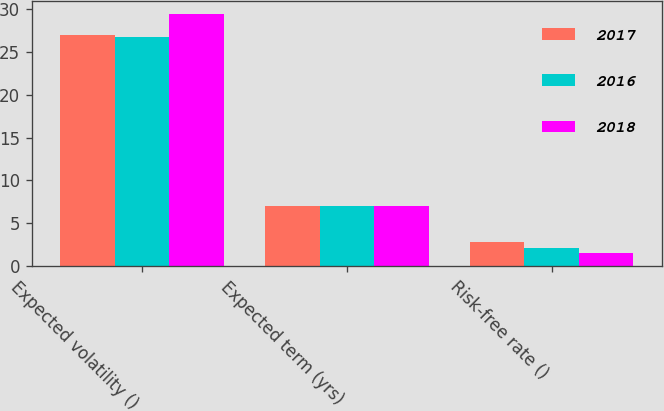Convert chart to OTSL. <chart><loc_0><loc_0><loc_500><loc_500><stacked_bar_chart><ecel><fcel>Expected volatility ()<fcel>Expected term (yrs)<fcel>Risk-free rate ()<nl><fcel>2017<fcel>27<fcel>7<fcel>2.8<nl><fcel>2016<fcel>26.7<fcel>7<fcel>2.1<nl><fcel>2018<fcel>29.4<fcel>7<fcel>1.5<nl></chart> 